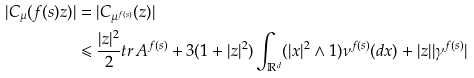<formula> <loc_0><loc_0><loc_500><loc_500>| C _ { \mu } ( f ( s ) z ) | & = | C _ { \mu ^ { f ( s ) } } ( z ) | \\ & \leqslant \frac { | z | ^ { 2 } } { 2 } t r \, A ^ { f ( s ) } + 3 ( 1 + | z | ^ { 2 } ) \int _ { \mathbb { R } ^ { d } } ( | x | ^ { 2 } \land 1 ) \nu ^ { f ( s ) } ( d x ) + | z | | \gamma ^ { f ( s ) } |</formula> 